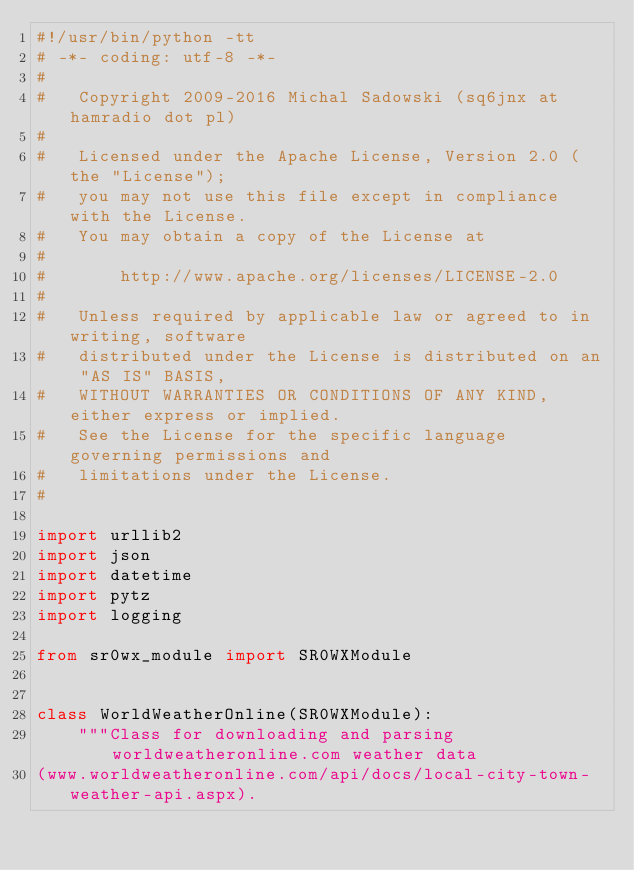<code> <loc_0><loc_0><loc_500><loc_500><_Python_>#!/usr/bin/python -tt
# -*- coding: utf-8 -*-
#
#   Copyright 2009-2016 Michal Sadowski (sq6jnx at hamradio dot pl)
#
#   Licensed under the Apache License, Version 2.0 (the "License");
#   you may not use this file except in compliance with the License.
#   You may obtain a copy of the License at
#
#       http://www.apache.org/licenses/LICENSE-2.0
#
#   Unless required by applicable law or agreed to in writing, software
#   distributed under the License is distributed on an "AS IS" BASIS,
#   WITHOUT WARRANTIES OR CONDITIONS OF ANY KIND, either express or implied.
#   See the License for the specific language governing permissions and
#   limitations under the License.
#

import urllib2
import json
import datetime
import pytz
import logging

from sr0wx_module import SR0WXModule


class WorldWeatherOnline(SR0WXModule):
    """Class for downloading and parsing worldweatheronline.com weather data
(www.worldweatheronline.com/api/docs/local-city-town-weather-api.aspx).
</code> 